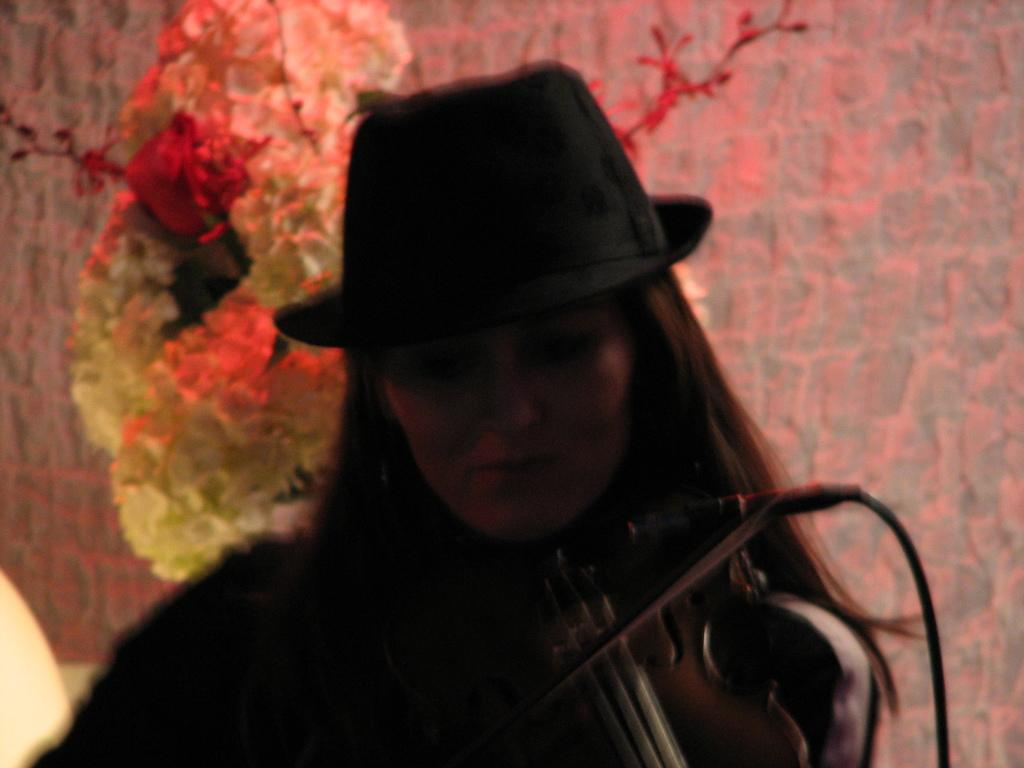Who is the main subject in the image? There is a woman in the image. What is the woman holding in the image? The woman is holding a musical instrument. What type of accessory is the woman wearing in the image? The woman is wearing a hat. What type of nut is the woman cracking in the image? There is no nut present in the image; the woman is holding a musical instrument. What type of trousers is the woman wearing in the image? The provided facts do not mention the type of trousers the woman is wearing, so we cannot answer this question definitively. 